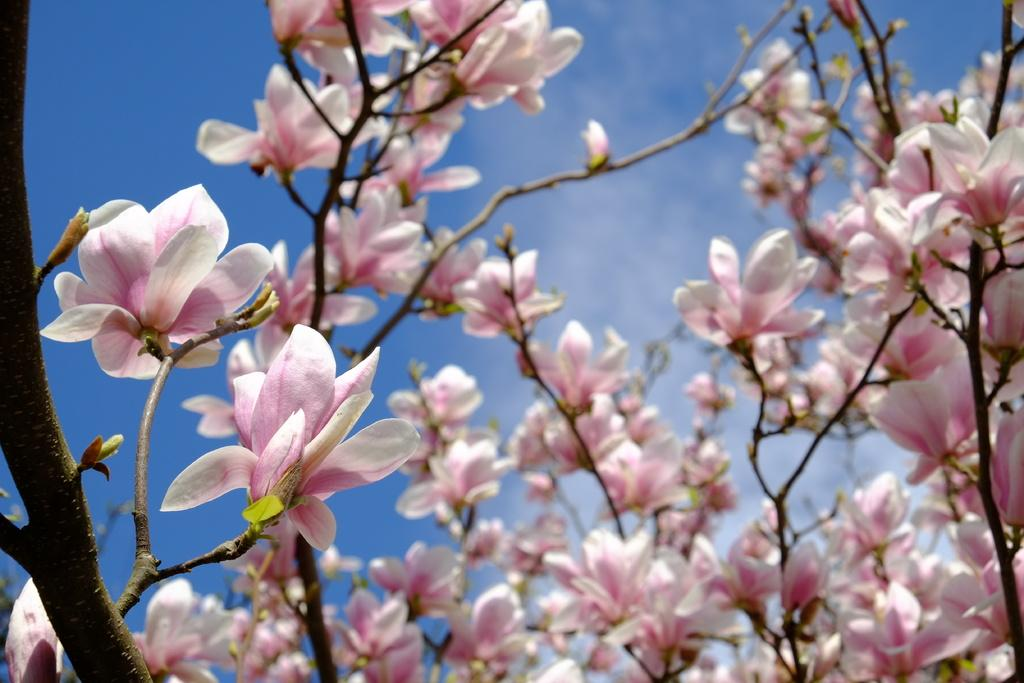What type of plants can be seen in the image? There are plants with flowers in the image. What can be seen in the background of the image? The sky is visible in the background of the image. What brand of toothpaste is being advertised in the image? There is no toothpaste or advertisement present in the image; it features plants with flowers and the sky in the background. 